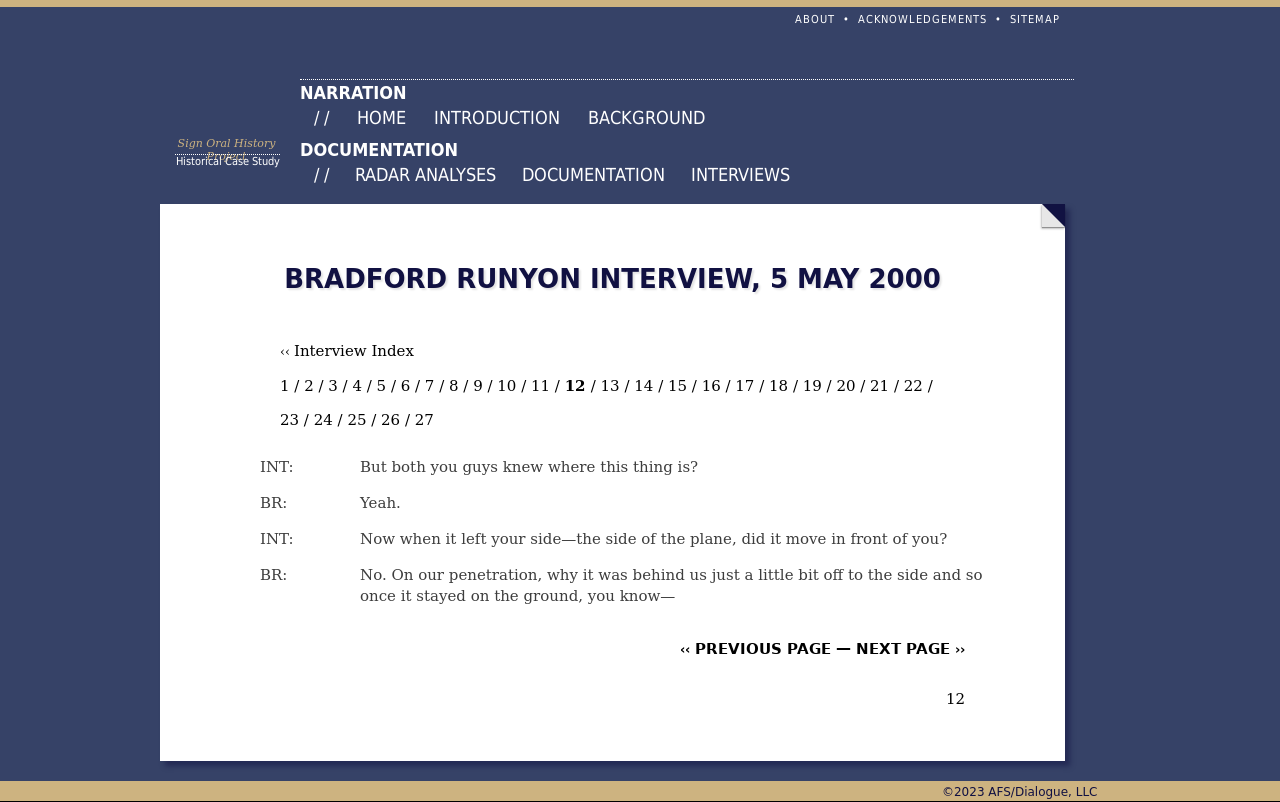Can you tell who conducted the interview and who the respondent was? From the image, it seems that the interview is being conducted with someone identified only by the initials 'BR', and the interviewer is referred to as 'INT'. Apart from these identifiers, the image does not provide specific names, requiring further context or access to the full document to identify the individuals accurately. 